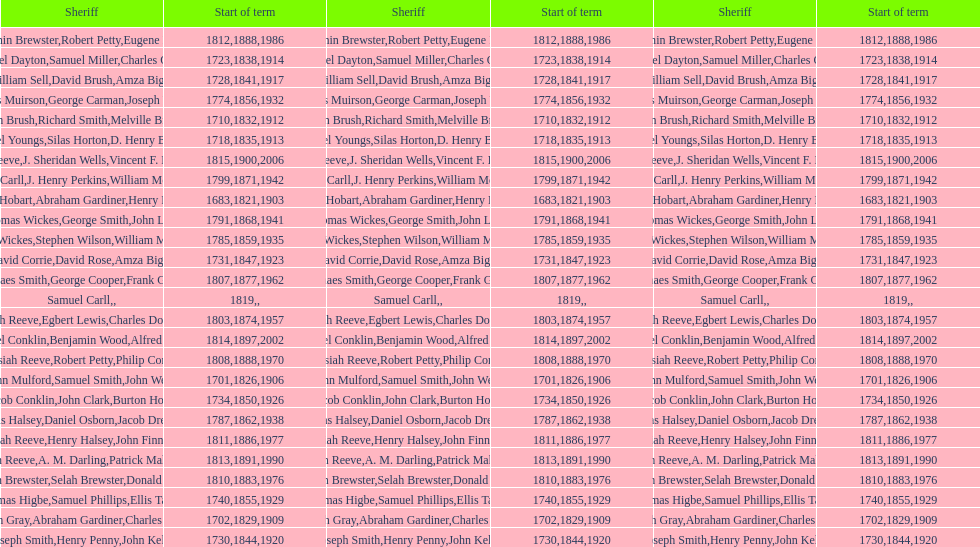When did the first sheriff's term start? 1683. 